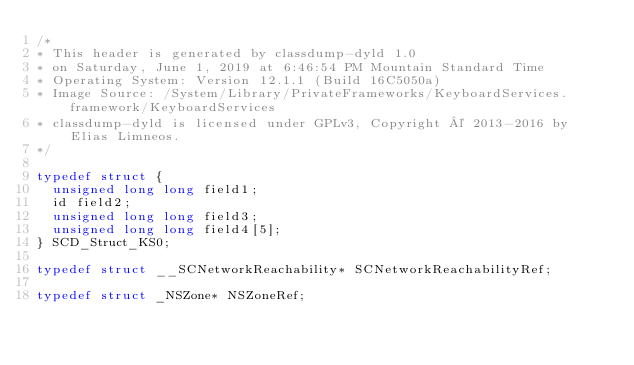Convert code to text. <code><loc_0><loc_0><loc_500><loc_500><_C_>/*
* This header is generated by classdump-dyld 1.0
* on Saturday, June 1, 2019 at 6:46:54 PM Mountain Standard Time
* Operating System: Version 12.1.1 (Build 16C5050a)
* Image Source: /System/Library/PrivateFrameworks/KeyboardServices.framework/KeyboardServices
* classdump-dyld is licensed under GPLv3, Copyright © 2013-2016 by Elias Limneos.
*/

typedef struct {
	unsigned long long field1;
	id field2;
	unsigned long long field3;
	unsigned long long field4[5];
} SCD_Struct_KS0;

typedef struct __SCNetworkReachability* SCNetworkReachabilityRef;

typedef struct _NSZone* NSZoneRef;

</code> 